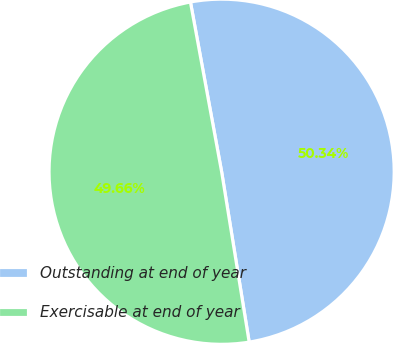Convert chart to OTSL. <chart><loc_0><loc_0><loc_500><loc_500><pie_chart><fcel>Outstanding at end of year<fcel>Exercisable at end of year<nl><fcel>50.34%<fcel>49.66%<nl></chart> 